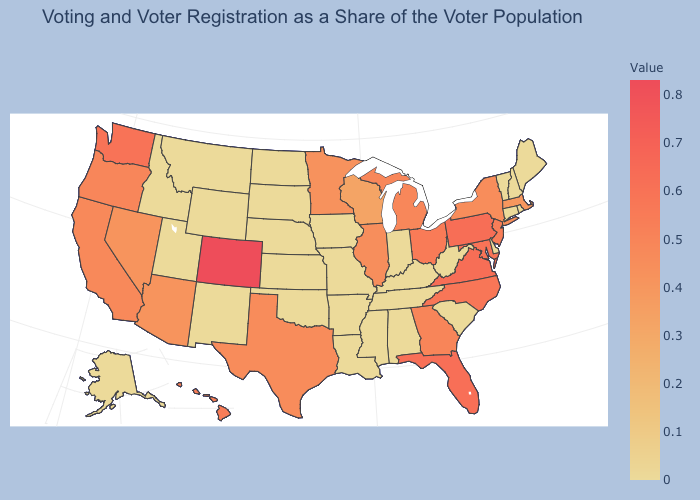Among the states that border Pennsylvania , which have the highest value?
Short answer required. Maryland. Which states have the lowest value in the USA?
Concise answer only. Alabama, Alaska, Arkansas, Connecticut, Delaware, Idaho, Indiana, Iowa, Kansas, Kentucky, Louisiana, Maine, Mississippi, Missouri, Montana, Nebraska, New Hampshire, New Mexico, North Dakota, Oklahoma, Rhode Island, South Carolina, South Dakota, Tennessee, Utah, Vermont, West Virginia, Wyoming. Among the states that border Wisconsin , does Michigan have the lowest value?
Quick response, please. No. Is the legend a continuous bar?
Write a very short answer. Yes. Which states have the lowest value in the USA?
Be succinct. Alabama, Alaska, Arkansas, Connecticut, Delaware, Idaho, Indiana, Iowa, Kansas, Kentucky, Louisiana, Maine, Mississippi, Missouri, Montana, Nebraska, New Hampshire, New Mexico, North Dakota, Oklahoma, Rhode Island, South Carolina, South Dakota, Tennessee, Utah, Vermont, West Virginia, Wyoming. Does Arkansas have the lowest value in the South?
Short answer required. Yes. 